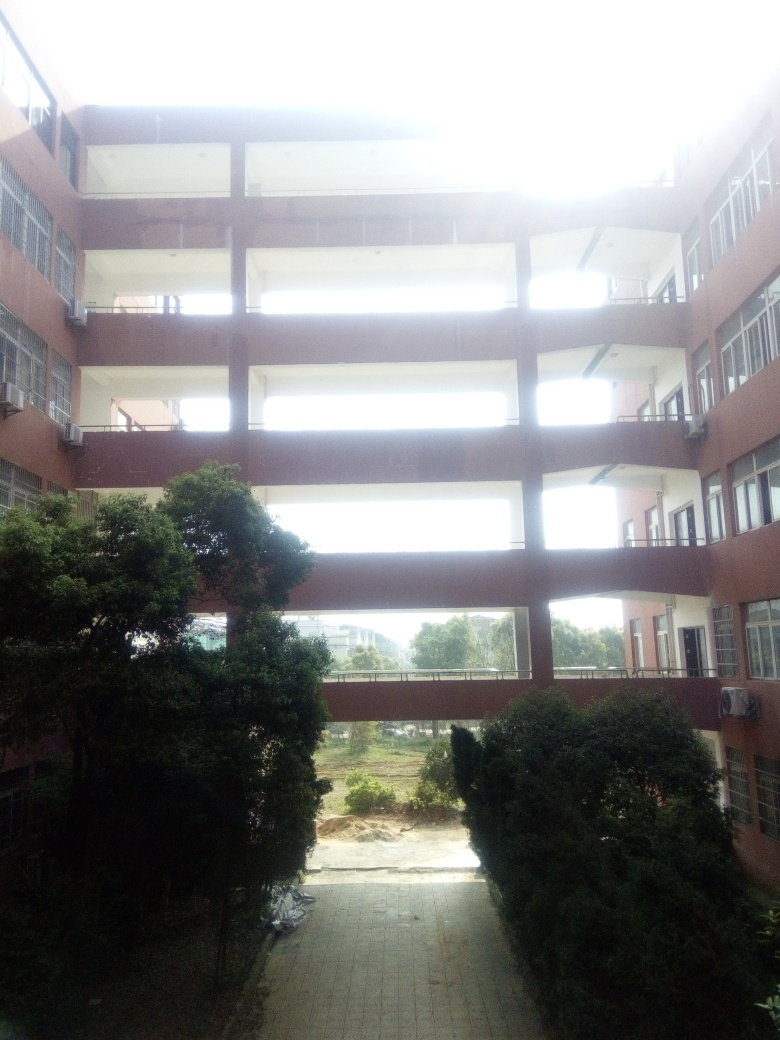What could be the function of this building? Based on the structural design and open layout, this building could serve several possible functions. It might be an educational institution like a university building, which often has similar open spaces to facilitate movement and interaction among students. Alternatively, it could be part of a public or office complex, designed to provide a communal space for people to gather and traverse between areas.  Are there any signs of renovations or constructions in the surroundings? In the image, the ground below the building is uneven, and there appears to be construction material or debris in the lower right corner. This suggests that there might be ongoing construction or renovation work in the surrounding areas, indicating that the space is in a state of development or maintenance. 